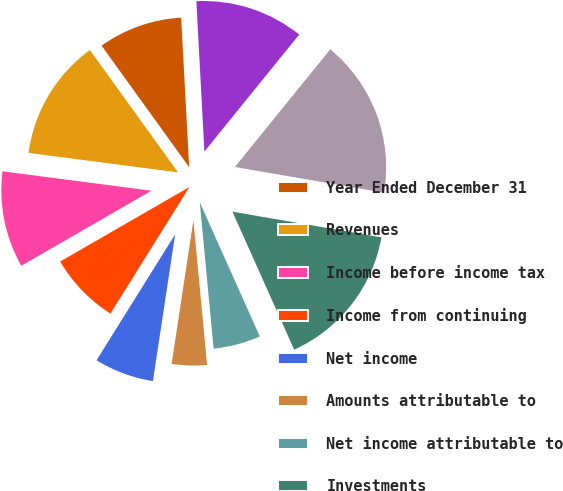Convert chart. <chart><loc_0><loc_0><loc_500><loc_500><pie_chart><fcel>Year Ended December 31<fcel>Revenues<fcel>Income before income tax<fcel>Income from continuing<fcel>Net income<fcel>Amounts attributable to<fcel>Net income attributable to<fcel>Investments<fcel>Total assets<fcel>Debt<nl><fcel>9.09%<fcel>12.99%<fcel>10.39%<fcel>7.79%<fcel>6.49%<fcel>3.9%<fcel>5.19%<fcel>15.58%<fcel>16.88%<fcel>11.69%<nl></chart> 